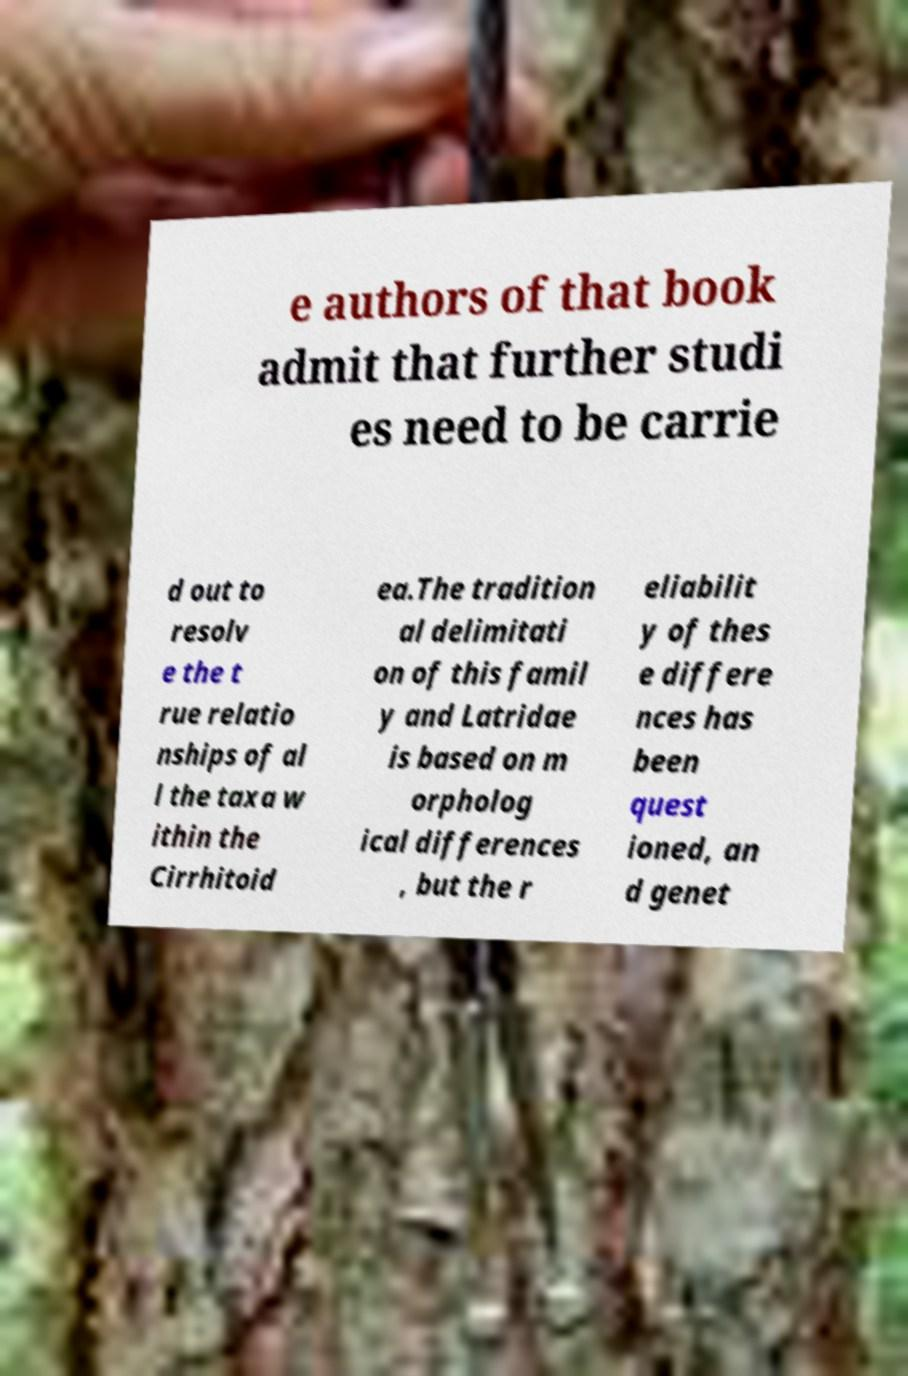What messages or text are displayed in this image? I need them in a readable, typed format. e authors of that book admit that further studi es need to be carrie d out to resolv e the t rue relatio nships of al l the taxa w ithin the Cirrhitoid ea.The tradition al delimitati on of this famil y and Latridae is based on m orpholog ical differences , but the r eliabilit y of thes e differe nces has been quest ioned, an d genet 